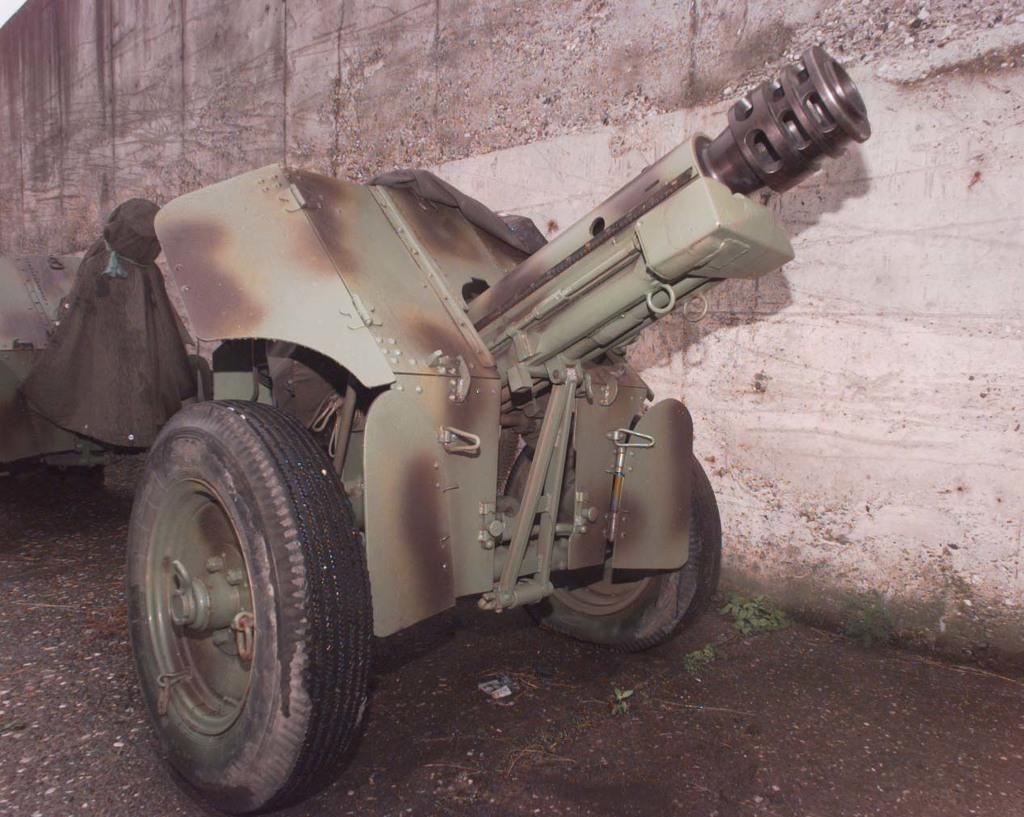What type of vehicle is in the image? There is a weapon vehicle with two wheels in the image. Where is the vehicle located? The vehicle is on a path in the image. What is beside the vehicle? There is a wall beside the vehicle in the image. What type of yarn is being used for teaching science in the image? There is no yarn or teaching activity present in the image; it features a weapon vehicle on a path with a wall beside it. 